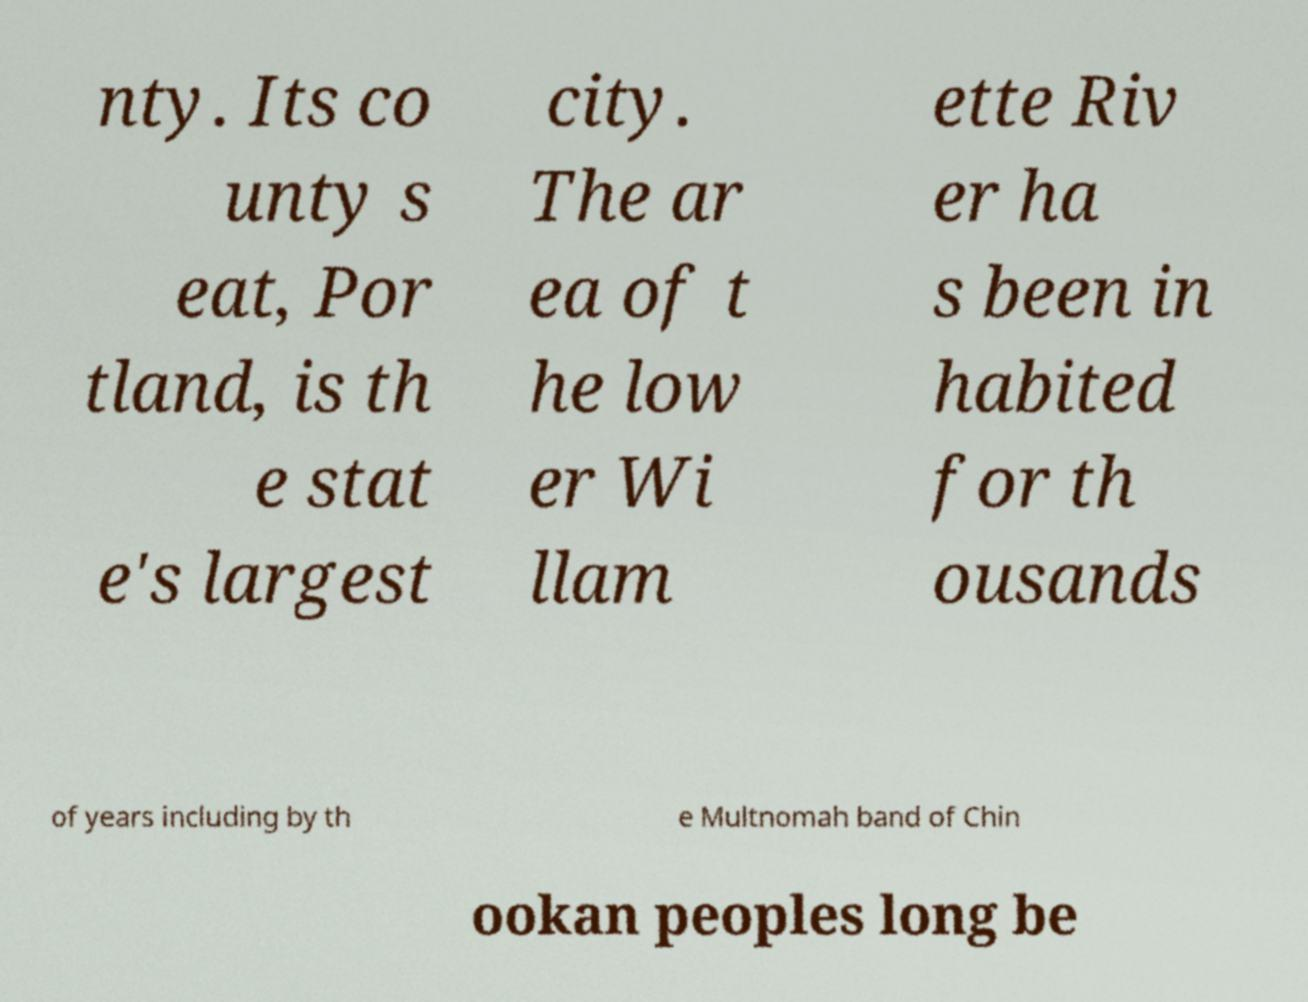Can you accurately transcribe the text from the provided image for me? nty. Its co unty s eat, Por tland, is th e stat e's largest city. The ar ea of t he low er Wi llam ette Riv er ha s been in habited for th ousands of years including by th e Multnomah band of Chin ookan peoples long be 